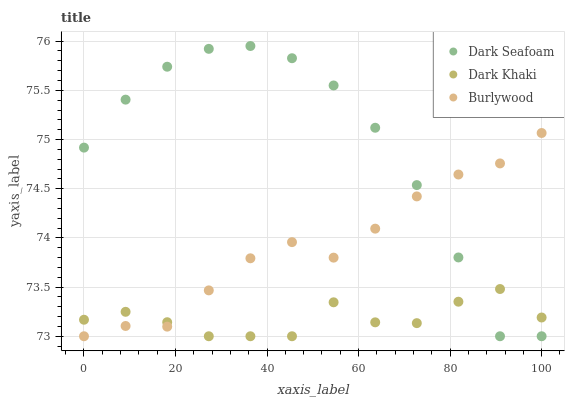Does Dark Khaki have the minimum area under the curve?
Answer yes or no. Yes. Does Dark Seafoam have the maximum area under the curve?
Answer yes or no. Yes. Does Burlywood have the minimum area under the curve?
Answer yes or no. No. Does Burlywood have the maximum area under the curve?
Answer yes or no. No. Is Burlywood the smoothest?
Answer yes or no. Yes. Is Dark Khaki the roughest?
Answer yes or no. Yes. Is Dark Seafoam the smoothest?
Answer yes or no. No. Is Dark Seafoam the roughest?
Answer yes or no. No. Does Dark Khaki have the lowest value?
Answer yes or no. Yes. Does Dark Seafoam have the highest value?
Answer yes or no. Yes. Does Burlywood have the highest value?
Answer yes or no. No. Does Dark Seafoam intersect Burlywood?
Answer yes or no. Yes. Is Dark Seafoam less than Burlywood?
Answer yes or no. No. Is Dark Seafoam greater than Burlywood?
Answer yes or no. No. 